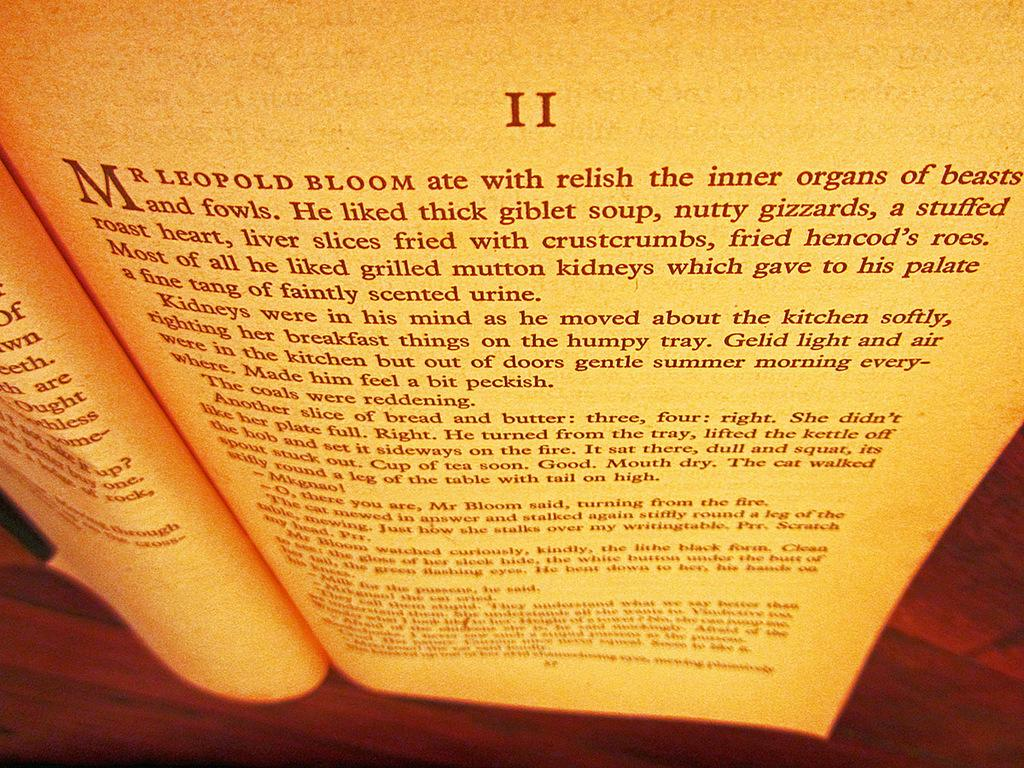What objects are present in the image? There are two papers in the image. Can you describe the appearance of the papers? The provided facts do not mention the appearance of the papers. Are the papers related to any specific topic or subject? The provided facts do not mention the topic or subject of the papers. Who is the owner of the plantation depicted in the image? There is no plantation depicted in the image; it only contains two papers. 